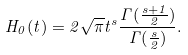<formula> <loc_0><loc_0><loc_500><loc_500>H _ { 0 } ( t ) = 2 \sqrt { \pi } t ^ { s } \frac { \Gamma ( \frac { s + 1 } { 2 } ) } { \Gamma ( \frac { s } { 2 } ) } .</formula> 